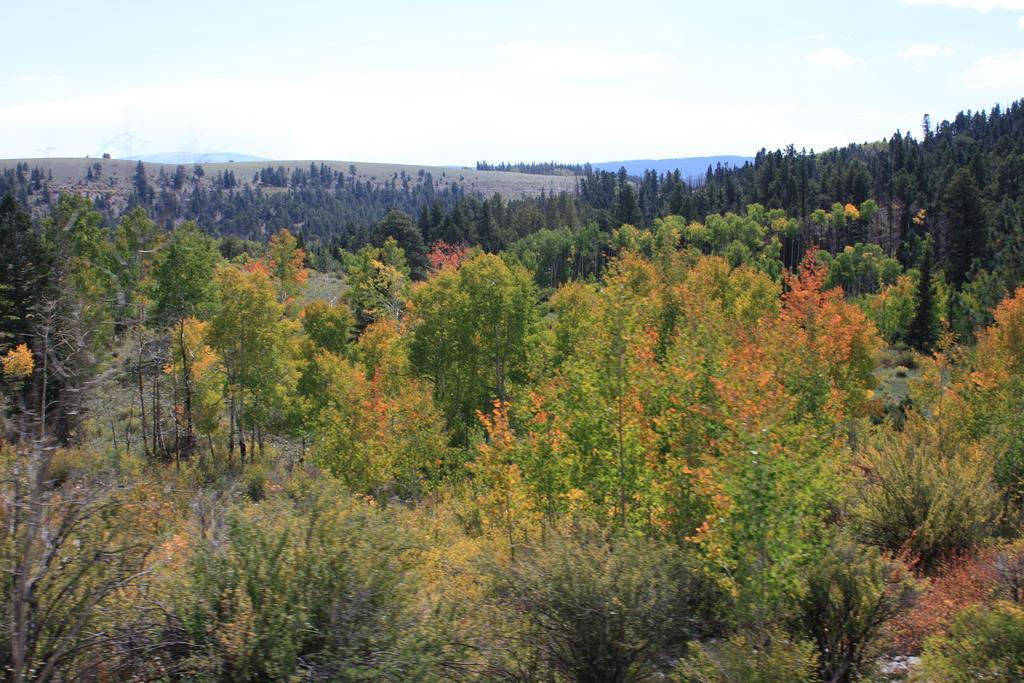Describe this image in one or two sentences. In the picture we can see many trees and in the background also we can see many trees, hills and sky. 